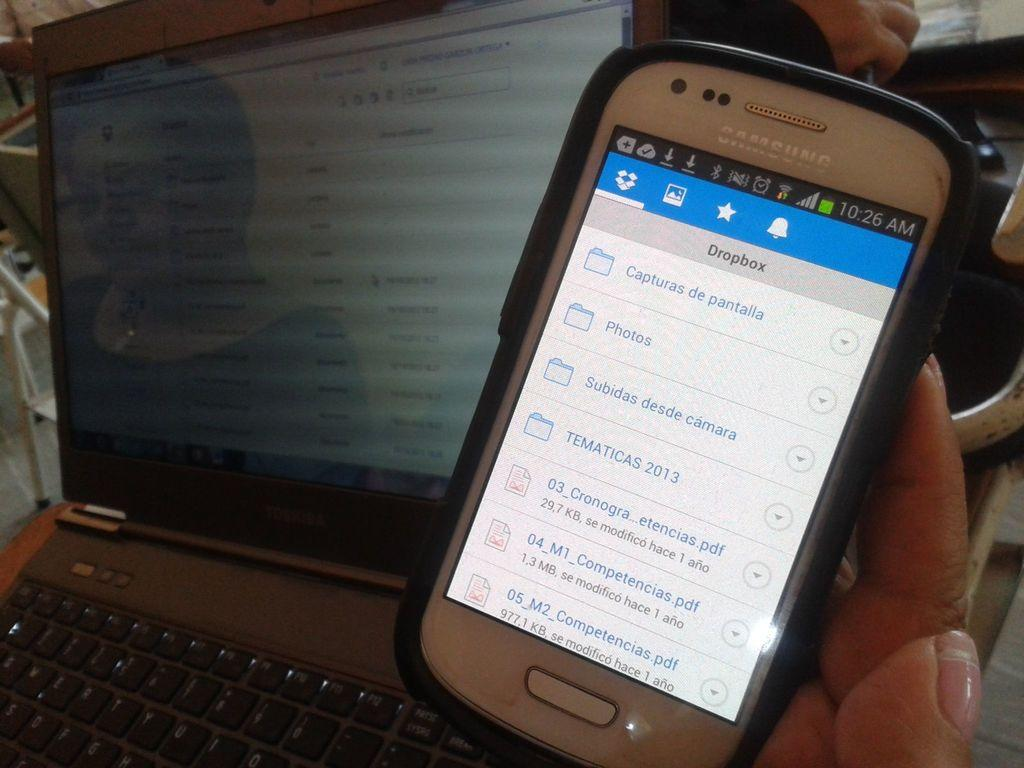<image>
Provide a brief description of the given image. A Samsung cell phone displays a menu for the Dropbox app on its screen. 